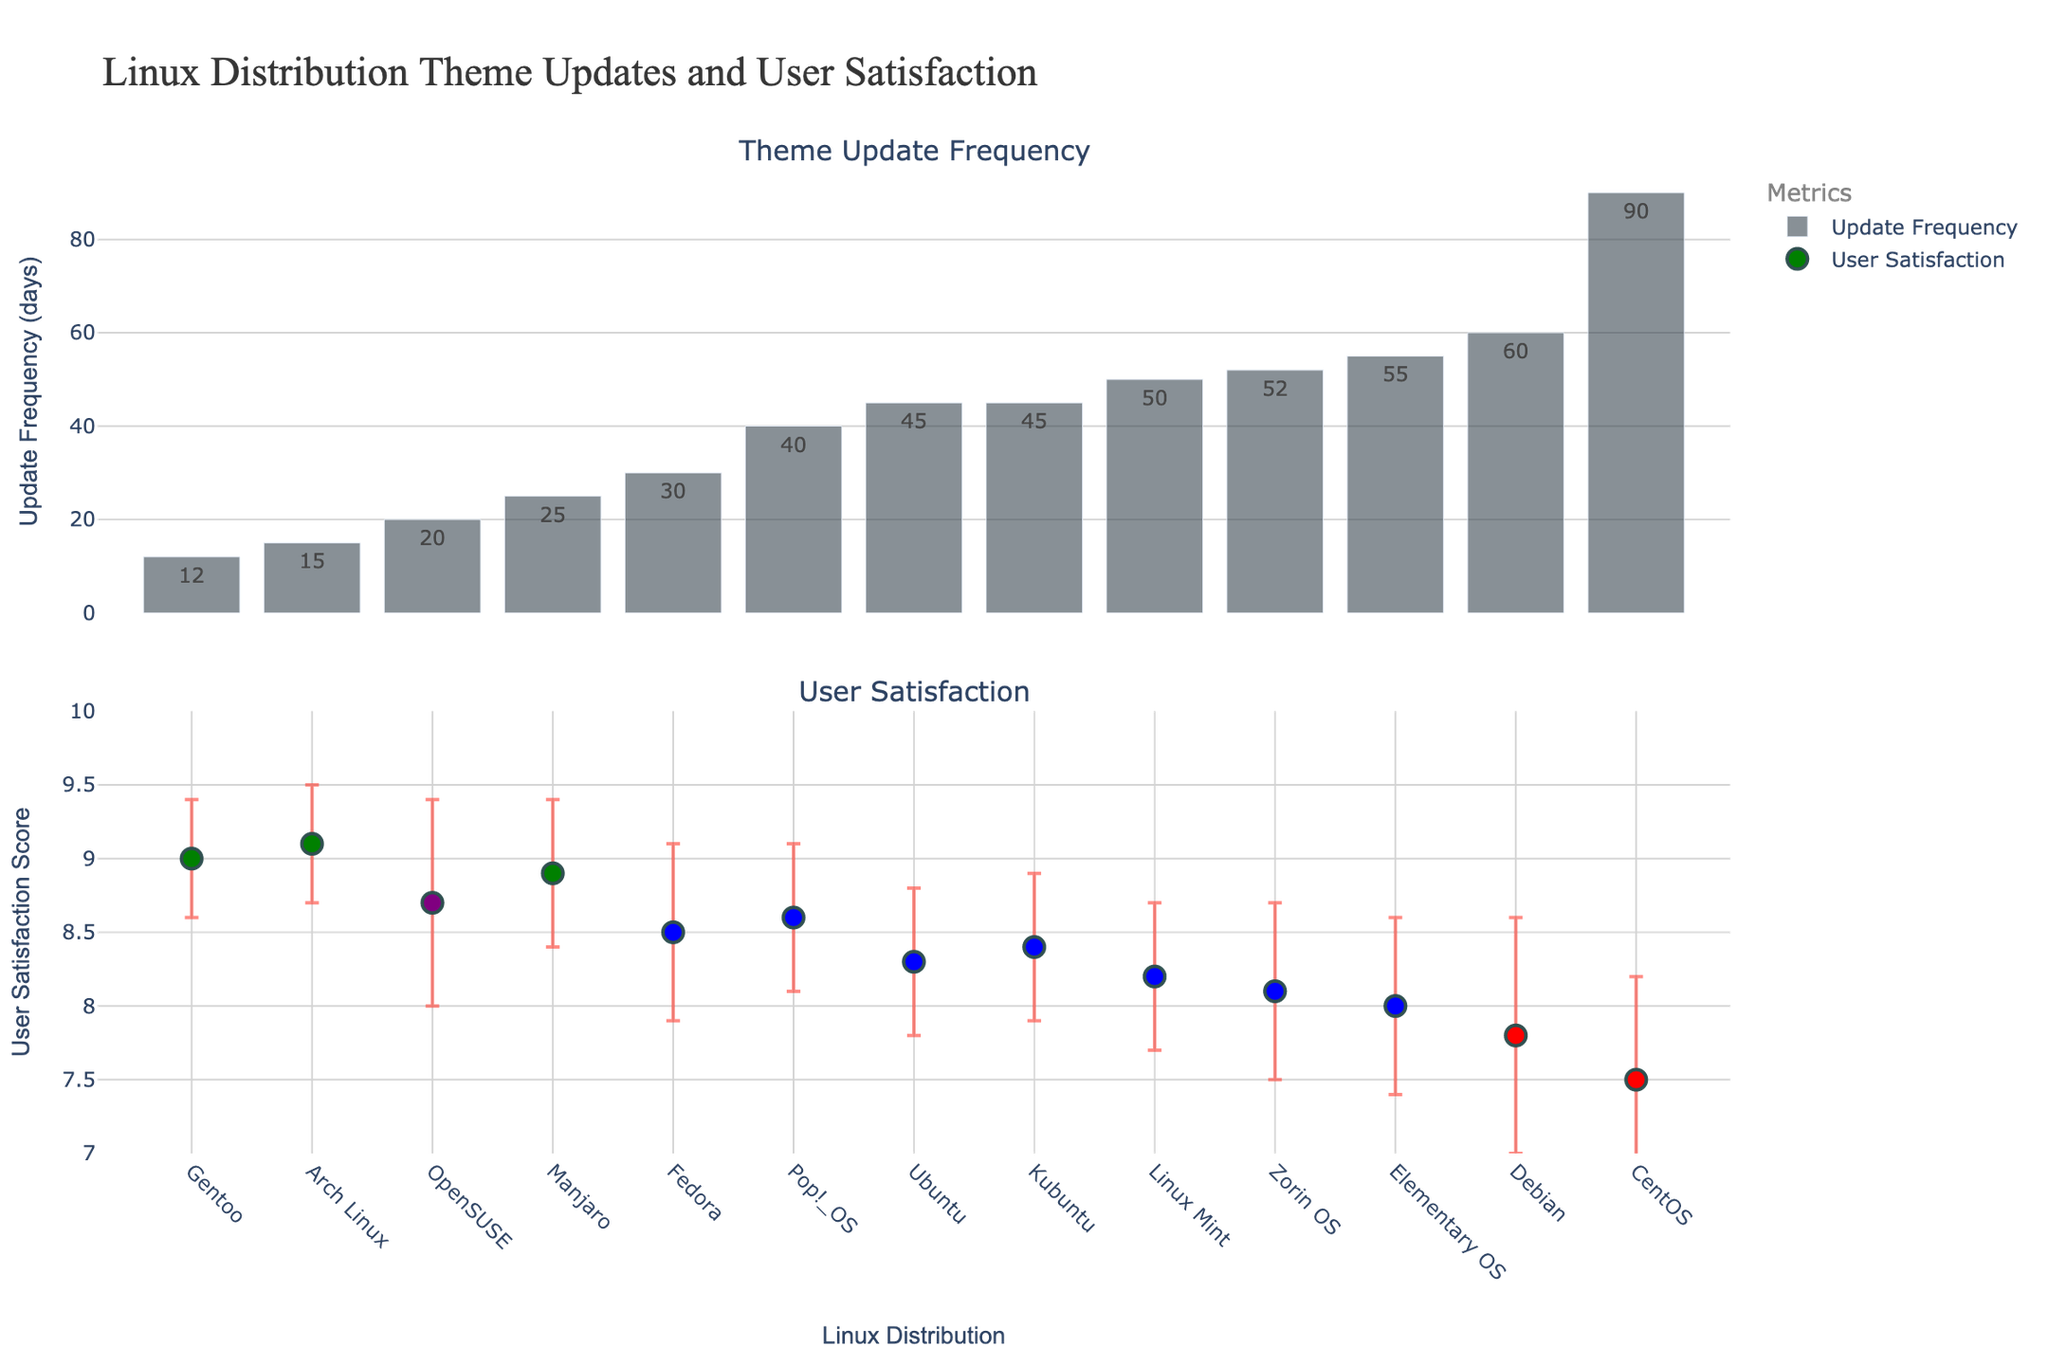Which Linux distribution has the shortest update frequency? The distribution with the shortest bar in the "Update Frequency" subplot represents the shortest update frequency. From the figure, it is clear that Gentoo has the shortest update frequency.
Answer: Gentoo What is the range of user satisfaction scores? The user satisfaction scores are displayed with error bars on the satisfaction subplot. The lowest mean satisfaction score is 7.5 for CentOS, and the highest is 9.1 for Arch Linux.
Answer: 7.5 to 9.1 Which distributions fall under the "Rolling" type, and what are their user satisfaction means? The color of the markers represents different types of distributions. Green markers indicate "Rolling" distributions. Arch Linux, Manjaro, and Gentoo are in the "Rolling" type with user satisfaction means of 9.1, 8.9, and 9.0, respectively.
Answer: Arch Linux: 9.1, Manjaro: 8.9, Gentoo: 9.0 How does the user satisfaction of Debian compare with that of Elementary OS? The user satisfaction means are shown in the satisfaction subplot, with error bars indicating the standard deviation. Debian has a score of 7.8, and Elementary OS has a score of 8.0. Elementary OS's satisfaction is slightly higher than Debian's.
Answer: Elementary OS: 8.0, Debian: 7.8 Which distribution has the highest standard deviation in user satisfaction? The size of the error bars in the satisfaction subplot indicate the standard deviation. OpenSUSE has the largest error bar, representing the highest standard deviation, which is 0.7.
Answer: OpenSUSE What is the average update frequency for mainstream distributions? Identify the mainstream distributions (blue markers) and calculate their average update frequency. The data points are Ubuntu (45), Fedora (30), Linux Mint (50), Elementary OS (55), Kubuntu (45), Zorin OS (52), and Pop!_OS (40). The average is (45 + 30 + 50 + 55 + 45 + 52 + 40) / 7 = 45.3.
Answer: 45.3 days Which distribution has the lowest user satisfaction among the stable types? The stable distributions are highlighted in red. Among the stable distributions, Debian and CentOS, CentOS has the lowest user satisfaction mean, which is 7.5.
Answer: CentOS Which distribution has the highest user satisfaction and what is its update frequency? The highest user satisfaction score is represented by Arch Linux with a mean score of 9.1. Its update frequency is shown in the first subplot, which is 15 days.
Answer: Arch Linux: 15 days What is the difference in user satisfaction between Fedora and Kubuntu? The user satisfaction means for Fedora and Kubuntu are 8.5 and 8.4, respectively. The difference is 8.5 - 8.4 = 0.1.
Answer: 0.1 Are there any distributions with an identical update frequency? If so, which ones? Check the update frequency subplot for bars of equal height. Both Ubuntu and Kubuntu have an update frequency of 45 days.
Answer: Ubuntu and Kubuntu 